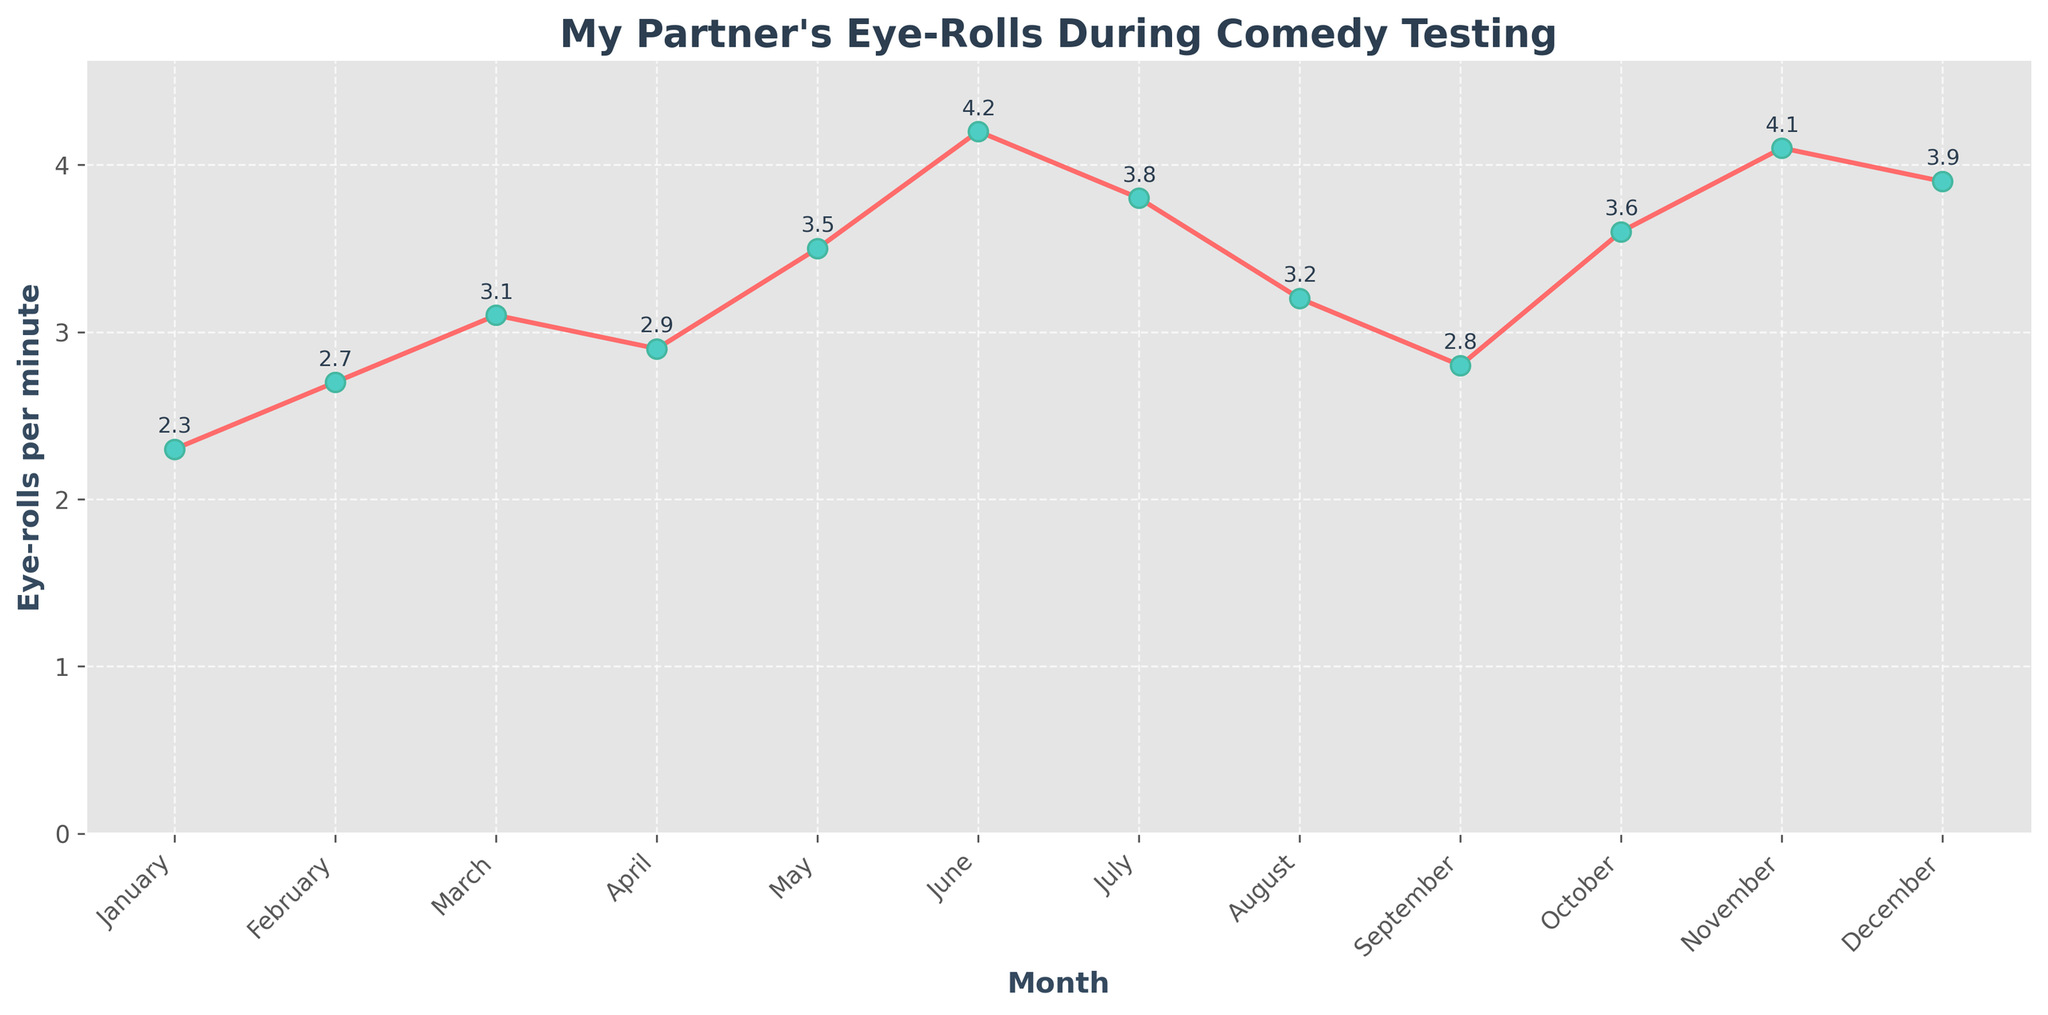What's the maximum frequency of eye-rolls per minute? By looking at the y-axis and finding the highest point on the line, the maximum frequency of eye-rolls per minute occurs in June with a value of 4.2.
Answer: 4.2 In which month did the frequency of eye-rolls per minute first exceed 3.0? From the plot, we observe the data points and see that in March, the frequency first exceeds 3.0 with a value of 3.1.
Answer: March How much did the frequency of eye-rolls per minute increase from January to June? The values for January and June are 2.3 and 4.2, respectively. Subtracting the January value from the June value we get 4.2 - 2.3 = 1.9.
Answer: 1.9 Which month had a lower frequency of eye-rolls per minute, July or December? By comparing the values for July and December, we see that July has a value of 3.8 and December has a value of 3.9, so July had a lower frequency.
Answer: July What's the average frequency of eye-rolls per minute across all months? Add all the monthly frequencies and divide by the number of months: (2.3 + 2.7 + 3.1 + 2.9 + 3.5 + 4.2 + 3.8 + 3.2 + 2.8 + 3.6 + 4.1 + 3.9) / 12. The sum is 40.1, so the average is 40.1 / 12 ≈ 3.34.
Answer: 3.34 Is there any month where the frequency of eye-rolls per minute decreased compared to the previous month? By analyzing the line plot, we see that from March (3.1) to April (2.9) and June (4.2) to July (3.8), there is a decrease in the frequency.
Answer: Yes What's the total frequency of eye-rolls per minute for the last three months of the year? Sum the values of the last three months: October (3.6), November (4.1), and December (3.9). The total is 3.6 + 4.1 + 3.9 = 11.6.
Answer: 11.6 Compare the frequency of eye-rolls per minute in the first half of the year (January to June) to the second half (July to December). Which half has a higher average frequency? Calculate the average for each half: First half - (2.3 + 2.7 + 3.1 + 2.9 + 3.5 + 4.2) / 6 = 18.7 / 6 ≈ 3.12; Second half - (3.8 + 3.2 + 2.8 + 3.6 + 4.1 + 3.9) / 6 = 21.4 / 6 ≈ 3.57. The second half has a higher average.
Answer: Second half 